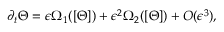Convert formula to latex. <formula><loc_0><loc_0><loc_500><loc_500>\partial _ { t } \Theta = \epsilon \Omega _ { 1 } ( [ \Theta ] ) + \epsilon ^ { 2 } \Omega _ { 2 } ( [ \Theta ] ) + O ( \epsilon ^ { 3 } ) ,</formula> 